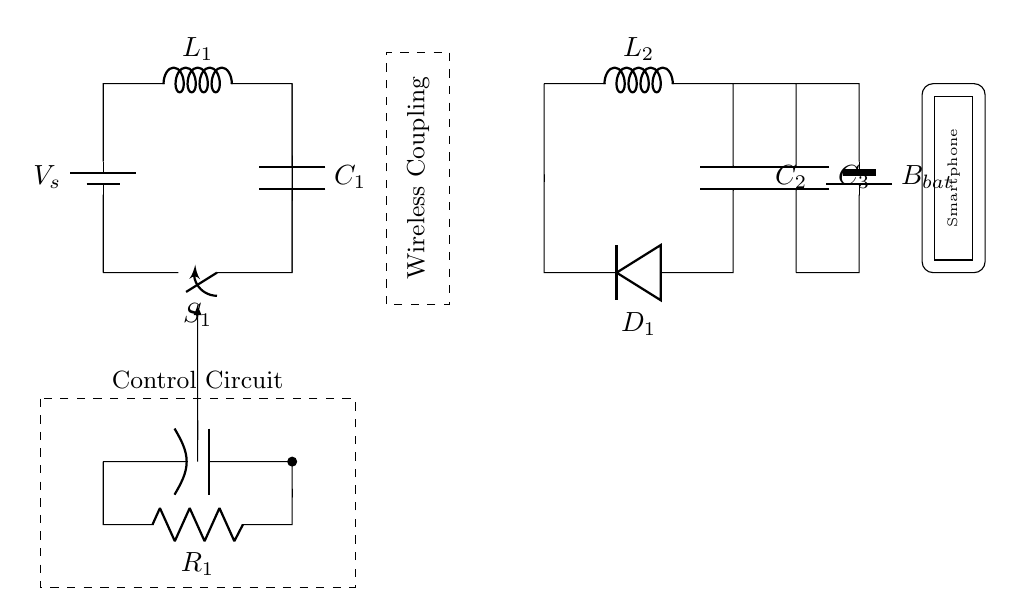What is the function of C1 in this circuit? C1 acts as a capacitor in the transmitter side, which helps in storing and smoothing the charge.
Answer: Capacitor What powers the circuit? The circuit is powered by the battery, which is labeled as Vs on the diagram.
Answer: Battery What is the role of L1? L1 serves as an inductor that stores energy in the magnetic field during operation.
Answer: Inductor What is the purpose of the dashed rectangle? The dashed rectangle indicates the wireless coupling area, essential for transferring energy wirelessly between the transmitter and receiver.
Answer: Wireless Coupling What type of diode is shown in this circuit? The diode in the circuit is a standard rectifying diode used for converting alternating current to direct current for battery charging.
Answer: Diode How many capacitors are in the receiver side? The receiver side contains two capacitors, C2 and C3, which are involved in energy storage to charge the battery.
Answer: Two What is the control circuit's function? The control circuit manages the operation of the wireless charging system, ensuring safety and effectiveness in charging the smartphone battery.
Answer: Management 